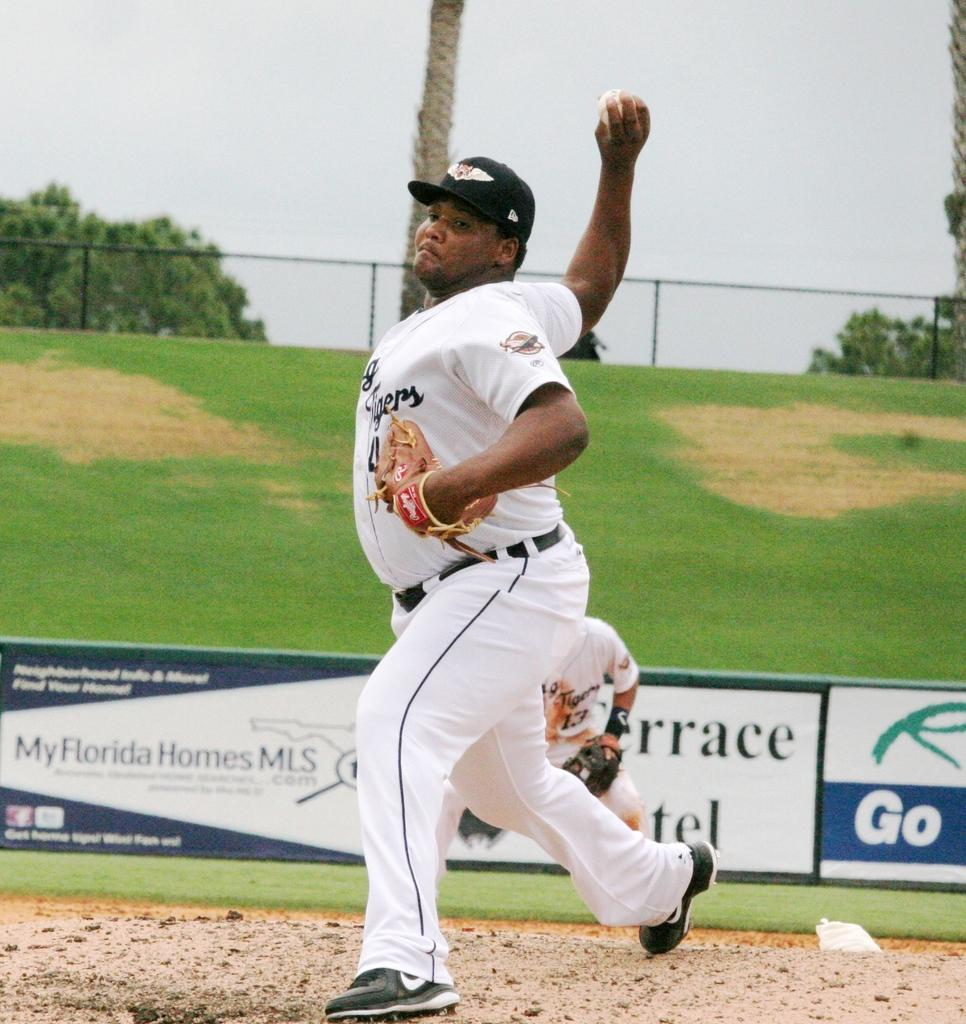<image>
Give a short and clear explanation of the subsequent image. A pitcher throws the ball on a field sponsored by My Florida Homes MLS. 